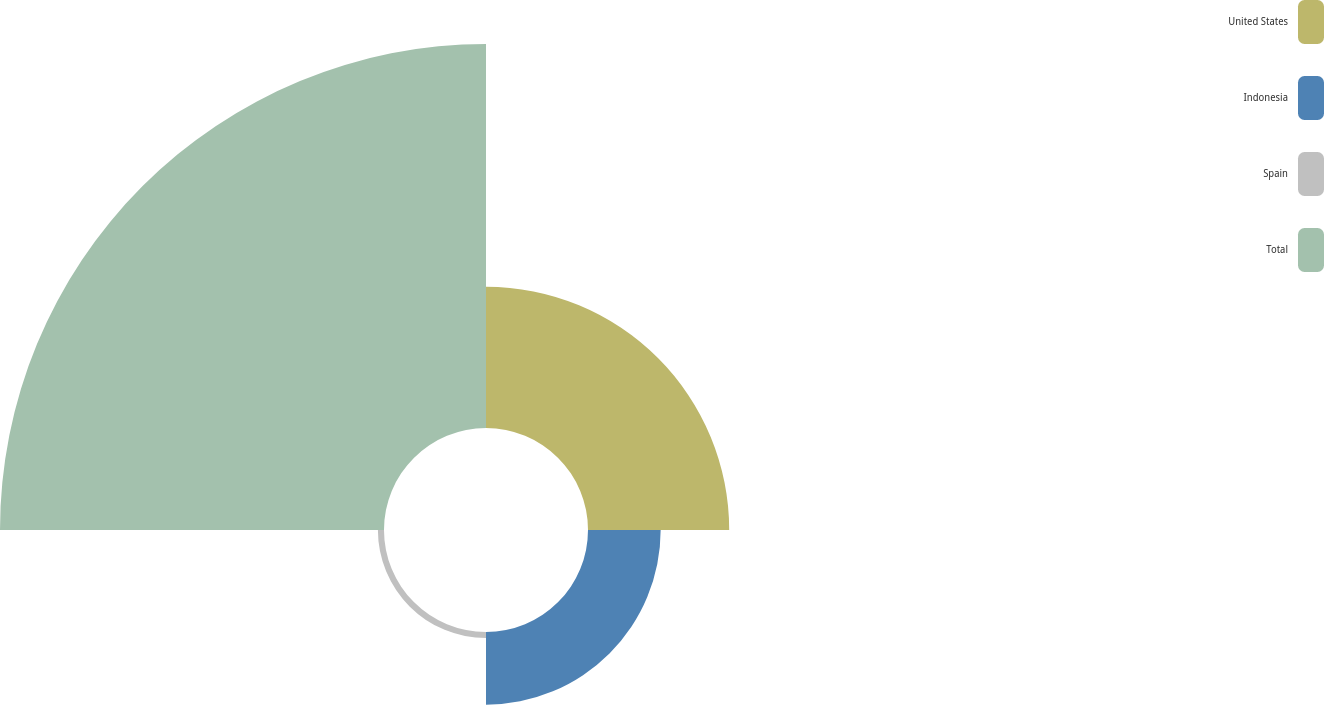Convert chart. <chart><loc_0><loc_0><loc_500><loc_500><pie_chart><fcel>United States<fcel>Indonesia<fcel>Spain<fcel>Total<nl><fcel>23.38%<fcel>12.03%<fcel>1.01%<fcel>63.58%<nl></chart> 